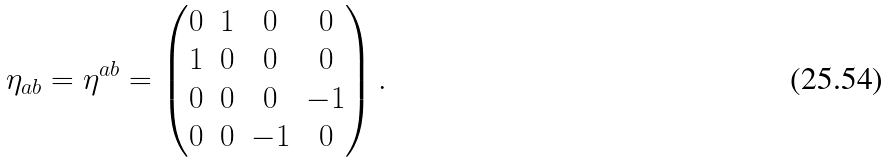<formula> <loc_0><loc_0><loc_500><loc_500>\eta _ { a b } = \eta ^ { a b } = \begin{pmatrix} 0 & 1 & 0 & 0 \\ 1 & 0 & 0 & 0 \\ 0 & 0 & 0 & - 1 \\ 0 & 0 & - 1 & 0 \\ \end{pmatrix} .</formula> 